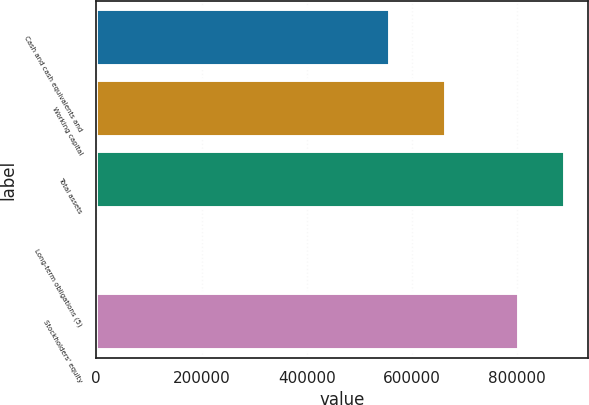Convert chart to OTSL. <chart><loc_0><loc_0><loc_500><loc_500><bar_chart><fcel>Cash and cash equivalents and<fcel>Working capital<fcel>Total assets<fcel>Long-term obligations (5)<fcel>Stockholders' equity<nl><fcel>557993<fcel>665062<fcel>890296<fcel>4011<fcel>803893<nl></chart> 